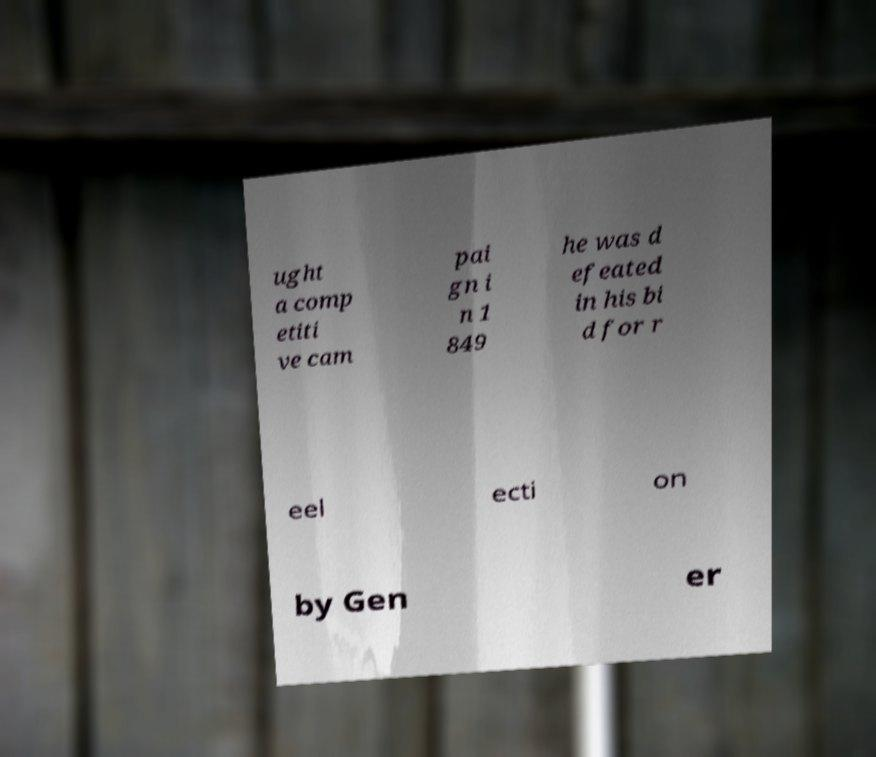Can you read and provide the text displayed in the image?This photo seems to have some interesting text. Can you extract and type it out for me? ught a comp etiti ve cam pai gn i n 1 849 he was d efeated in his bi d for r eel ecti on by Gen er 